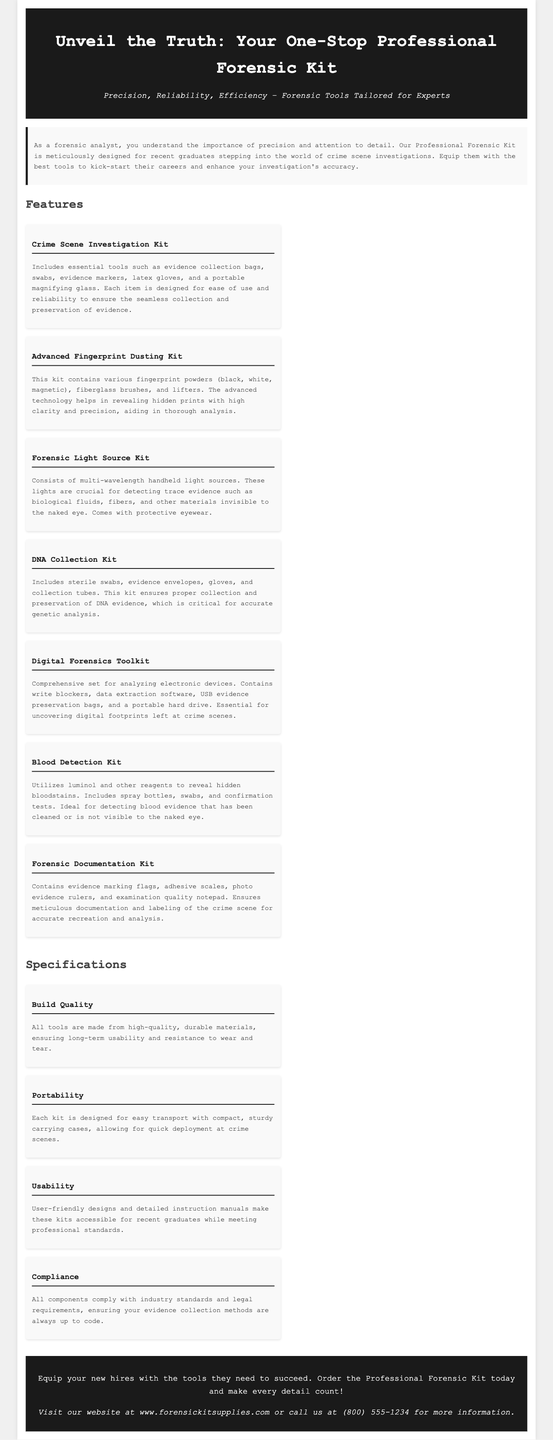What is the title of the advertisement? The title of the advertisement is prominently displayed at the top of the document.
Answer: Unveil the Truth: Your One-Stop Professional Forensic Kit What item is included in the Crime Scene Investigation Kit? The document lists several essential tools within this kit, highlighting one specific example.
Answer: Evidence collection bags How many feature items are there in total? The document outlines several features, and counting them provides the total count.
Answer: Seven What is a unique item found in the Digital Forensics Toolkit? The description of this kit mentions specific tools that are essential for digital analysis.
Answer: Write blockers What does the Forensic Light Source Kit consist of? The document details several components of this kit, identifying a particular type of item essential for its function.
Answer: Multi-wavelength handheld light sources What does the Blood Detection Kit utilize to reveal hidden bloodstains? The document specifies a particular chemical used in this kit, serving a key function.
Answer: Luminol What is the primary audience for this Professional Forensic Kit? The document clearly identifies who would benefit most from using this kit.
Answer: Recent graduates What is emphasized as critical for accurate genetic analysis? The description highlights the importance of a specific kit for the function it serves.
Answer: DNA Collection Kit What type of quality does the Build Quality specification mention? The document describes the construction quality of the tools in this kit.
Answer: High-quality, durable materials 